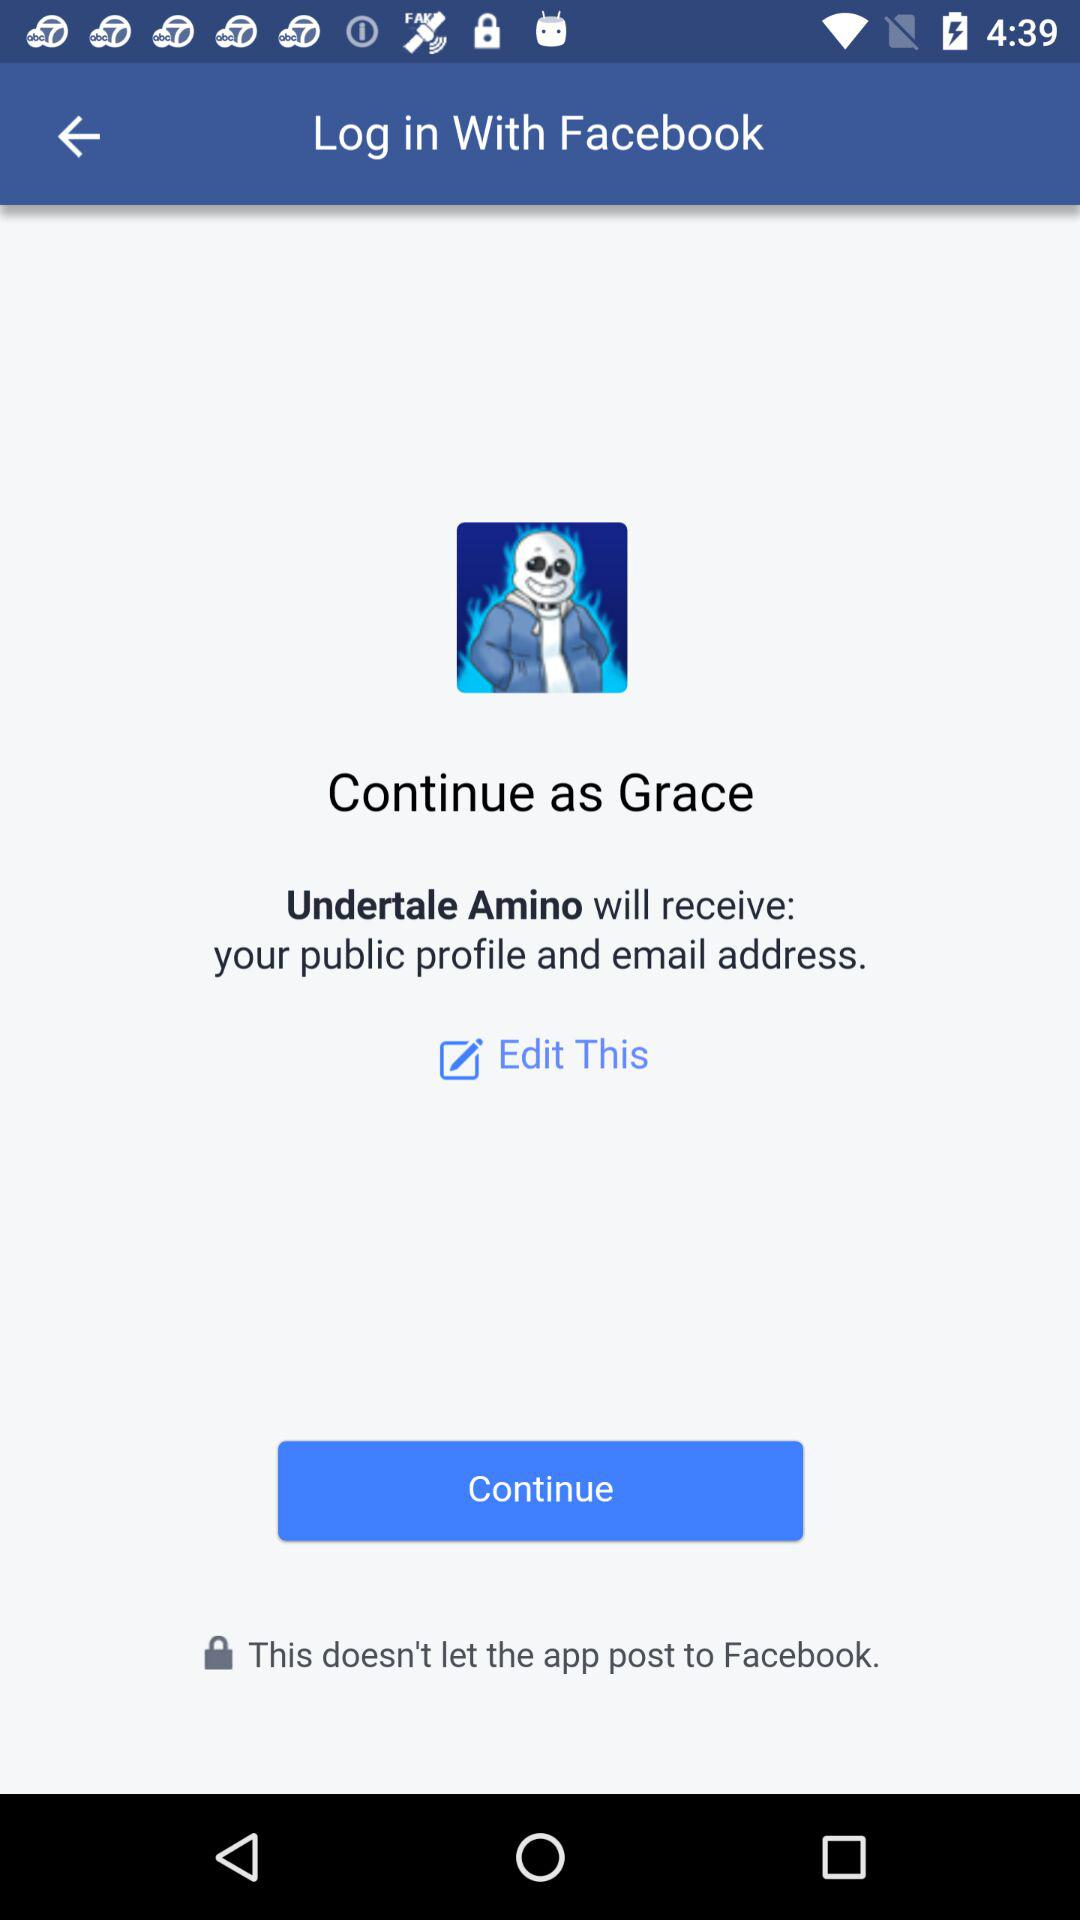With what application can we log in? You can log in with the "Facebook" application. 